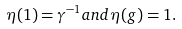<formula> <loc_0><loc_0><loc_500><loc_500>\eta ( 1 ) = \gamma ^ { - 1 } a n d \eta ( g ) = 1 .</formula> 